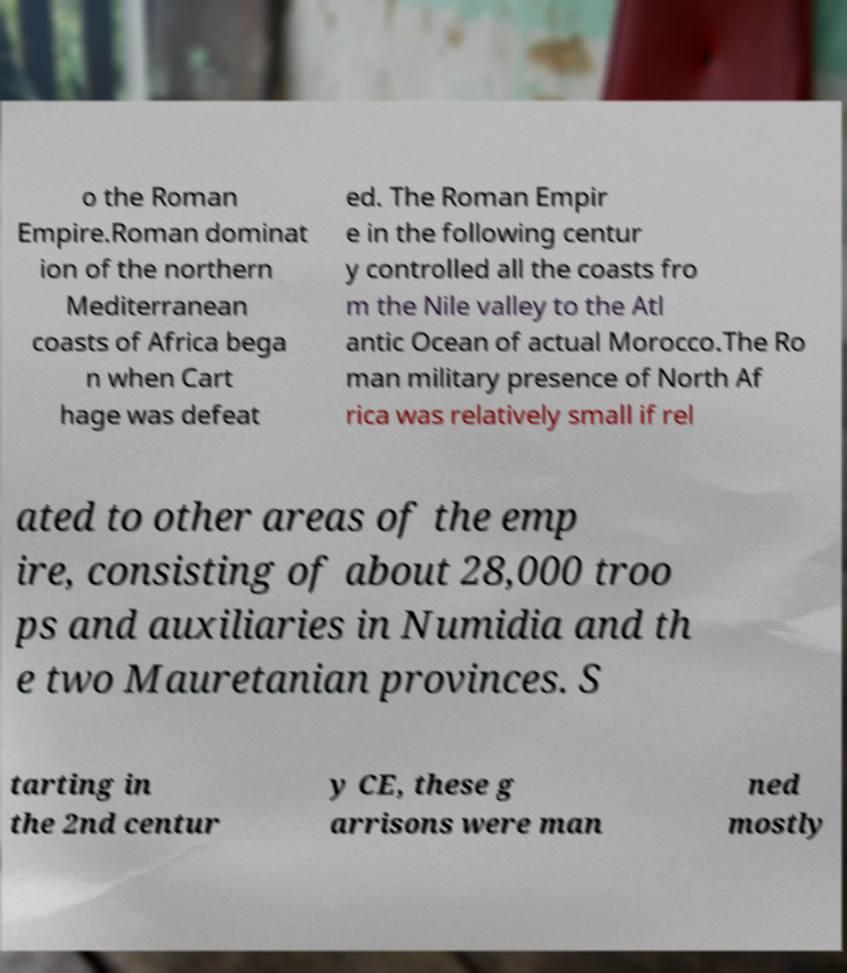Please read and relay the text visible in this image. What does it say? o the Roman Empire.Roman dominat ion of the northern Mediterranean coasts of Africa bega n when Cart hage was defeat ed. The Roman Empir e in the following centur y controlled all the coasts fro m the Nile valley to the Atl antic Ocean of actual Morocco.The Ro man military presence of North Af rica was relatively small if rel ated to other areas of the emp ire, consisting of about 28,000 troo ps and auxiliaries in Numidia and th e two Mauretanian provinces. S tarting in the 2nd centur y CE, these g arrisons were man ned mostly 